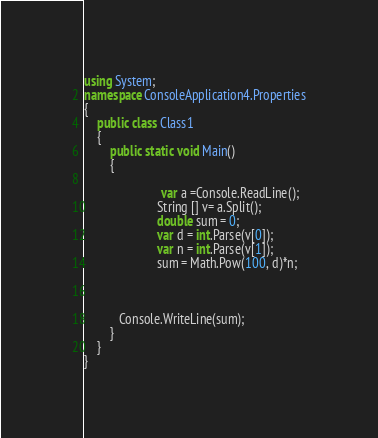Convert code to text. <code><loc_0><loc_0><loc_500><loc_500><_C#_>using System;
namespace ConsoleApplication4.Properties
{
    public class Class1
    {
        public static void Main()
        {
            
                        var a =Console.ReadLine();
                       String [] v= a.Split();
                       double sum = 0;
                       var d = int.Parse(v[0]);
                       var n = int.Parse(v[1]);
                       sum = Math.Pow(100, d)*n;

                       
 
           Console.WriteLine(sum);
        }
    }
}</code> 